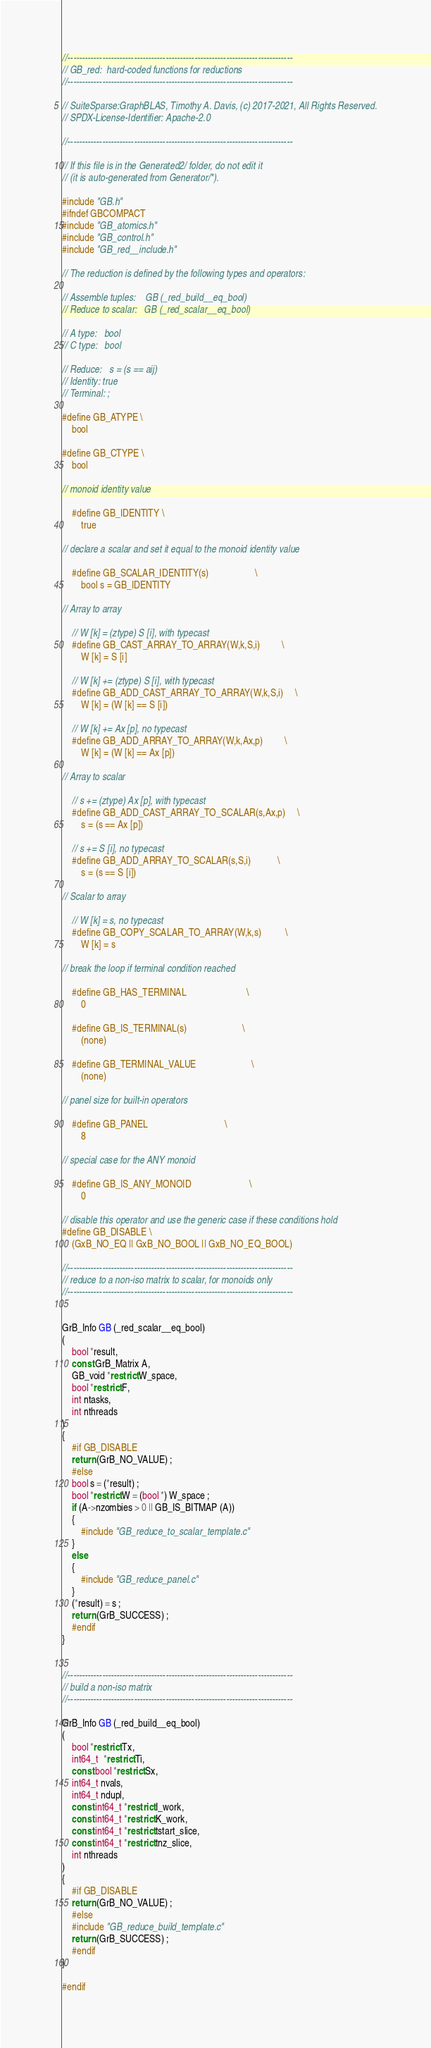Convert code to text. <code><loc_0><loc_0><loc_500><loc_500><_C_>//------------------------------------------------------------------------------
// GB_red:  hard-coded functions for reductions
//------------------------------------------------------------------------------

// SuiteSparse:GraphBLAS, Timothy A. Davis, (c) 2017-2021, All Rights Reserved.
// SPDX-License-Identifier: Apache-2.0

//------------------------------------------------------------------------------

// If this file is in the Generated2/ folder, do not edit it
// (it is auto-generated from Generator/*).

#include "GB.h"
#ifndef GBCOMPACT
#include "GB_atomics.h"
#include "GB_control.h" 
#include "GB_red__include.h"

// The reduction is defined by the following types and operators:

// Assemble tuples:    GB (_red_build__eq_bool)
// Reduce to scalar:   GB (_red_scalar__eq_bool)

// A type:   bool
// C type:   bool

// Reduce:   s = (s == aij)
// Identity: true
// Terminal: ;

#define GB_ATYPE \
    bool

#define GB_CTYPE \
    bool

// monoid identity value

    #define GB_IDENTITY \
        true

// declare a scalar and set it equal to the monoid identity value

    #define GB_SCALAR_IDENTITY(s)                   \
        bool s = GB_IDENTITY

// Array to array

    // W [k] = (ztype) S [i], with typecast
    #define GB_CAST_ARRAY_TO_ARRAY(W,k,S,i)         \
        W [k] = S [i]

    // W [k] += (ztype) S [i], with typecast
    #define GB_ADD_CAST_ARRAY_TO_ARRAY(W,k,S,i)     \
        W [k] = (W [k] == S [i])

    // W [k] += Ax [p], no typecast
    #define GB_ADD_ARRAY_TO_ARRAY(W,k,Ax,p)         \
        W [k] = (W [k] == Ax [p])  

// Array to scalar

    // s += (ztype) Ax [p], with typecast
    #define GB_ADD_CAST_ARRAY_TO_SCALAR(s,Ax,p)     \
        s = (s == Ax [p])

    // s += S [i], no typecast
    #define GB_ADD_ARRAY_TO_SCALAR(s,S,i)           \
        s = (s == S [i])

// Scalar to array

    // W [k] = s, no typecast
    #define GB_COPY_SCALAR_TO_ARRAY(W,k,s)          \
        W [k] = s

// break the loop if terminal condition reached

    #define GB_HAS_TERMINAL                         \
        0

    #define GB_IS_TERMINAL(s)                       \
        (none)

    #define GB_TERMINAL_VALUE                       \
        (none)

// panel size for built-in operators

    #define GB_PANEL                                \
        8

// special case for the ANY monoid

    #define GB_IS_ANY_MONOID                        \
        0

// disable this operator and use the generic case if these conditions hold
#define GB_DISABLE \
    (GxB_NO_EQ || GxB_NO_BOOL || GxB_NO_EQ_BOOL)

//------------------------------------------------------------------------------
// reduce to a non-iso matrix to scalar, for monoids only
//------------------------------------------------------------------------------


GrB_Info GB (_red_scalar__eq_bool)
(
    bool *result,
    const GrB_Matrix A,
    GB_void *restrict W_space,
    bool *restrict F,
    int ntasks,
    int nthreads
)
{ 
    #if GB_DISABLE
    return (GrB_NO_VALUE) ;
    #else
    bool s = (*result) ;
    bool *restrict W = (bool *) W_space ;
    if (A->nzombies > 0 || GB_IS_BITMAP (A))
    {
        #include "GB_reduce_to_scalar_template.c"
    }
    else
    {
        #include "GB_reduce_panel.c"
    }
    (*result) = s ;
    return (GrB_SUCCESS) ;
    #endif
}


//------------------------------------------------------------------------------
// build a non-iso matrix
//------------------------------------------------------------------------------

GrB_Info GB (_red_build__eq_bool)
(
    bool *restrict Tx,
    int64_t  *restrict Ti,
    const bool *restrict Sx,
    int64_t nvals,
    int64_t ndupl,
    const int64_t *restrict I_work,
    const int64_t *restrict K_work,
    const int64_t *restrict tstart_slice,
    const int64_t *restrict tnz_slice,
    int nthreads
)
{ 
    #if GB_DISABLE
    return (GrB_NO_VALUE) ;
    #else
    #include "GB_reduce_build_template.c"
    return (GrB_SUCCESS) ;
    #endif
}

#endif

</code> 